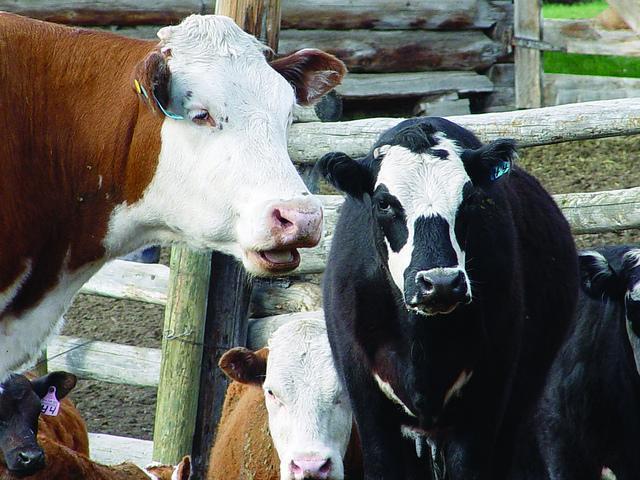How many cows have brown markings?
Give a very brief answer. 3. How many cows are there?
Give a very brief answer. 5. How many airplane lights are red?
Give a very brief answer. 0. 